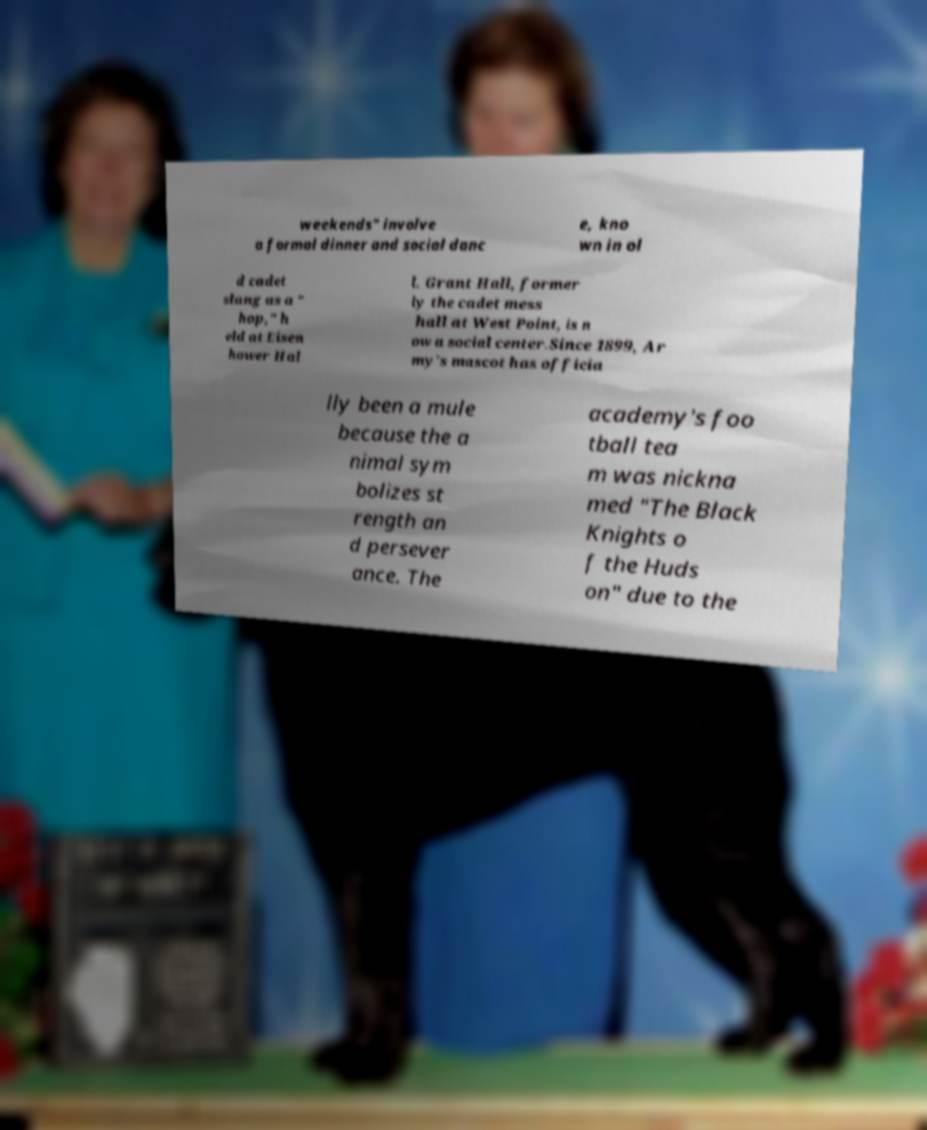Can you read and provide the text displayed in the image?This photo seems to have some interesting text. Can you extract and type it out for me? weekends" involve a formal dinner and social danc e, kno wn in ol d cadet slang as a " hop," h eld at Eisen hower Hal l. Grant Hall, former ly the cadet mess hall at West Point, is n ow a social center.Since 1899, Ar my's mascot has officia lly been a mule because the a nimal sym bolizes st rength an d persever ance. The academy's foo tball tea m was nickna med "The Black Knights o f the Huds on" due to the 